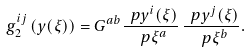Convert formula to latex. <formula><loc_0><loc_0><loc_500><loc_500>g _ { 2 } ^ { i j } \left ( y ( \xi ) \right ) = G ^ { a b } \frac { \ p y ^ { i } ( \xi ) } { \ p \xi ^ { a } } \, \frac { \ p y ^ { j } ( \xi ) } { \ p \xi ^ { b } } .</formula> 